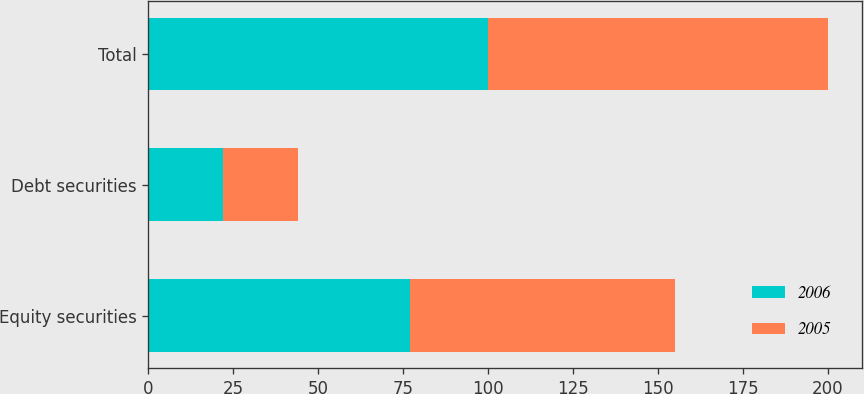<chart> <loc_0><loc_0><loc_500><loc_500><stacked_bar_chart><ecel><fcel>Equity securities<fcel>Debt securities<fcel>Total<nl><fcel>2006<fcel>77<fcel>22<fcel>100<nl><fcel>2005<fcel>78<fcel>22<fcel>100<nl></chart> 